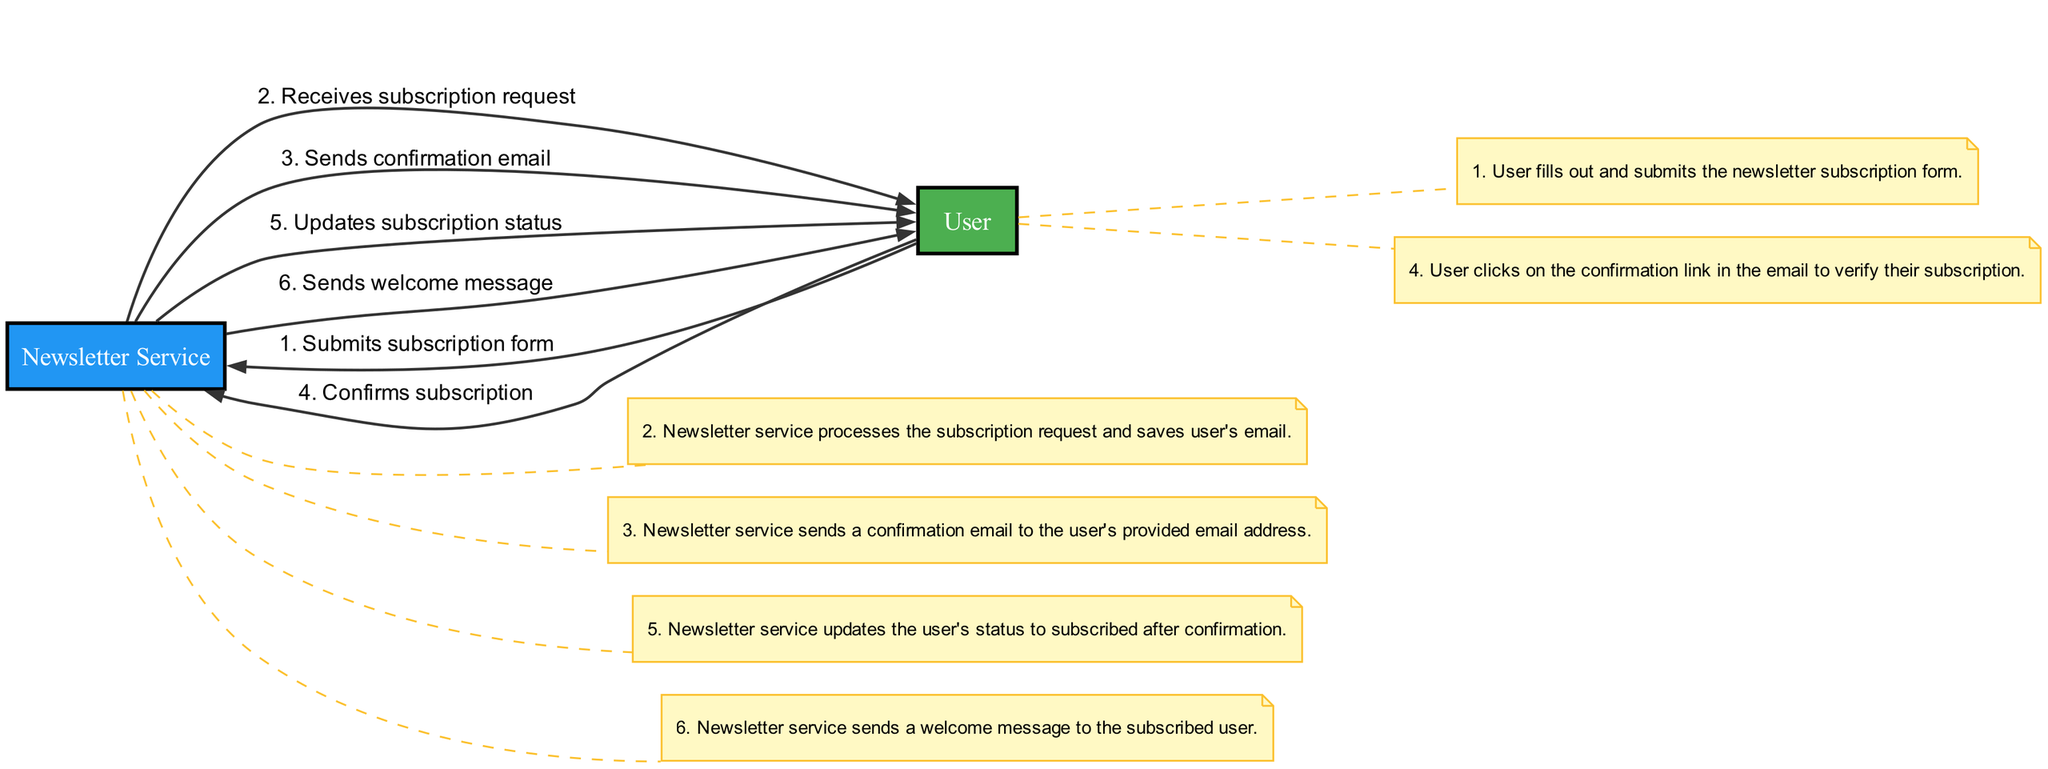What is the first action in the sequence? The first action in the sequence is performed by the User, who submits the subscription form. This sets off the process of subscribing to the newsletter.
Answer: Submits subscription form How many total actions are there in this sequence? Counting all the actions listed in the sequence, there are a total of six actions from beginning to end. This includes each distinct action performed by the User and the Newsletter Service.
Answer: Six What is the last message sent in the sequence? The last message sent is the welcome message, which is dispatched to the User after their subscription is confirmed, marking the completion of the subscription process.
Answer: Sends welcome message Which actor sends a confirmation email? The actor responsible for sending the confirmation email is the Newsletter Service, as indicated in the flow of actions that follow the submission of the subscription form.
Answer: Newsletter Service What action comes immediately after the user confirms their subscription? Immediately after the User confirms their subscription, the next action is the Newsletter Service updating the subscription status to reflect that the User is now subscribed.
Answer: Updates subscription status How many messages are sent by the Newsletter Service? The Newsletter Service sends three messages throughout the sequence: the confirmation email, the update of the subscription status, and the welcome message.
Answer: Three What does the User do after receiving the confirmation email? After receiving the confirmation email, the User clicks on the confirmation link in the email to verify their subscription, which is a necessary step in the subscription process.
Answer: Confirms subscription Which action follows the subscription status update? The action that follows the update of the subscription status is the sending of the welcome message to the User, completing the series of interactions.
Answer: Sends welcome message 